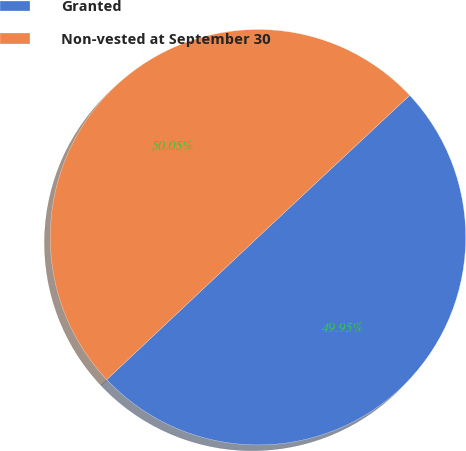Convert chart. <chart><loc_0><loc_0><loc_500><loc_500><pie_chart><fcel>Granted<fcel>Non-vested at September 30<nl><fcel>49.95%<fcel>50.05%<nl></chart> 